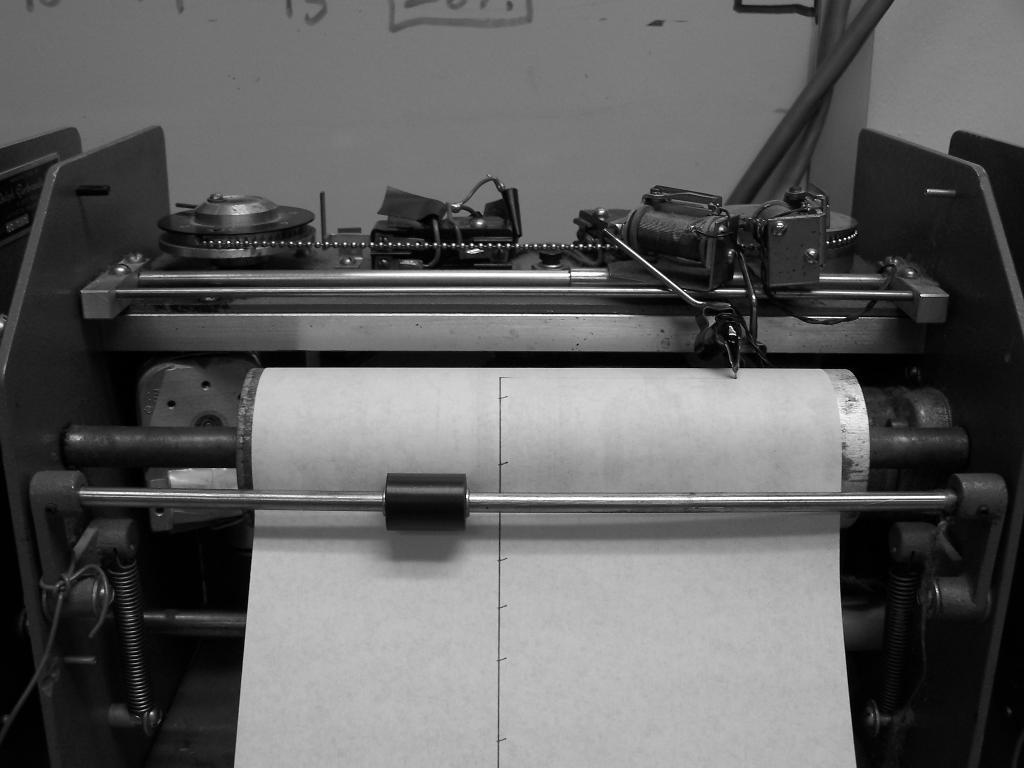Where was the image taken? The image is taken indoors. What can be seen in the background of the image? There is a wall in the background of the image. What is the main subject of the image? The main subject of the image is a printing machine. What is the printing machine doing in the image? The printing machine has a paper in it, suggesting it is in use. How many kittens are playing with the family in the image? There are no kittens or family members present in the image; it features a printing machine with a paper in it. 